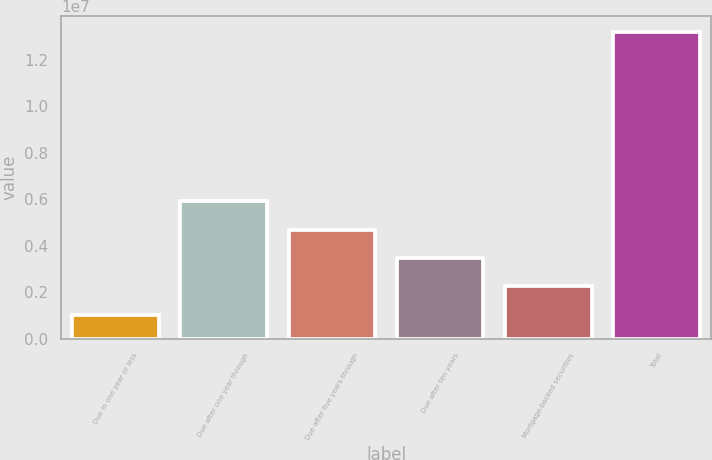<chart> <loc_0><loc_0><loc_500><loc_500><bar_chart><fcel>Due in one year or less<fcel>Due after one year through<fcel>Due after five years through<fcel>Due after ten years<fcel>Mortgage-backed securities<fcel>Total<nl><fcel>1.04271e+06<fcel>5.90755e+06<fcel>4.69134e+06<fcel>3.47513e+06<fcel>2.25892e+06<fcel>1.32048e+07<nl></chart> 